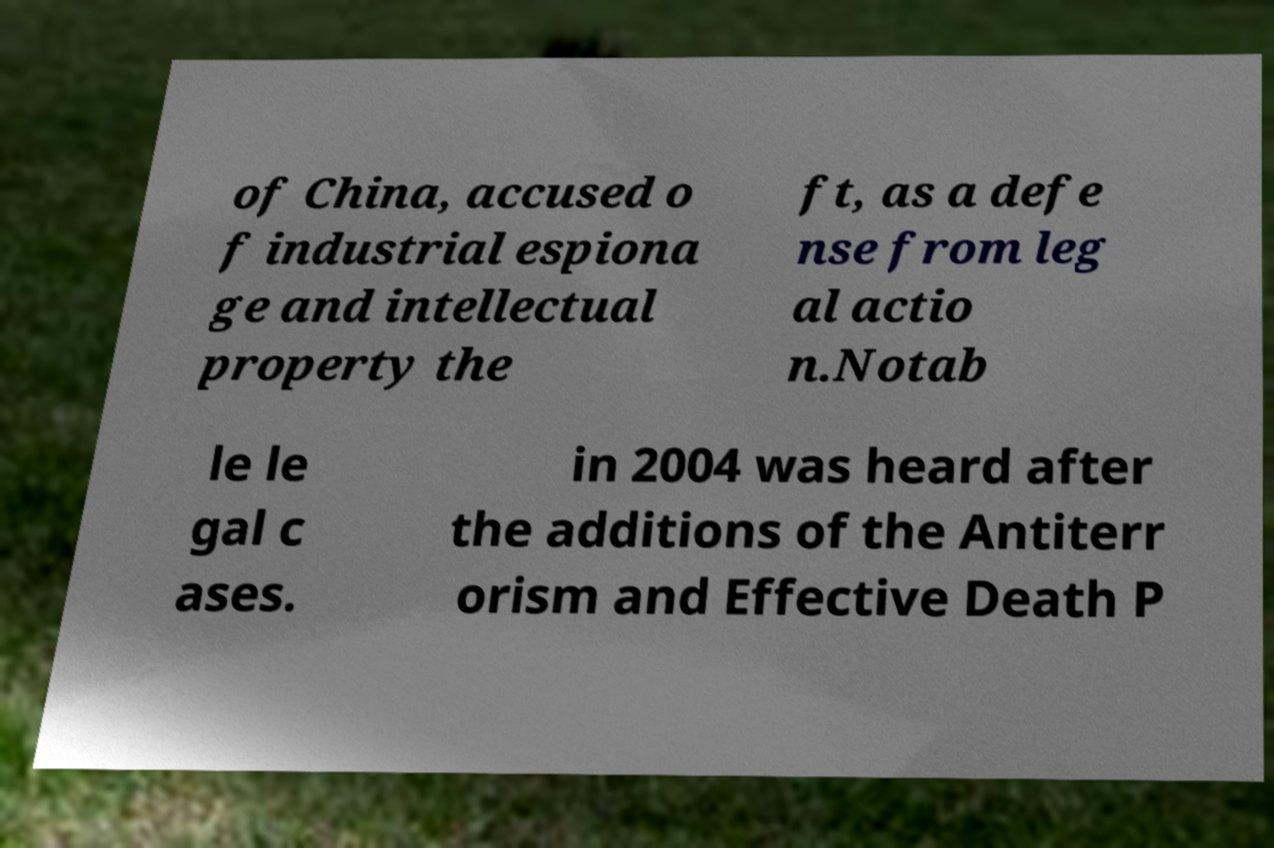Please identify and transcribe the text found in this image. of China, accused o f industrial espiona ge and intellectual property the ft, as a defe nse from leg al actio n.Notab le le gal c ases. in 2004 was heard after the additions of the Antiterr orism and Effective Death P 